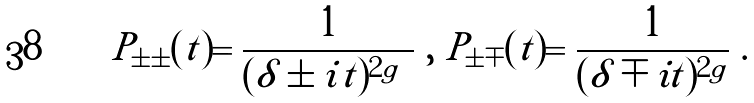Convert formula to latex. <formula><loc_0><loc_0><loc_500><loc_500>P _ { \pm \pm } ( t ) = \frac { 1 } { ( \delta \pm i | t | ) ^ { 2 g } } \ , \ P _ { \pm \mp } ( t ) = \frac { 1 } { ( \delta \mp i t ) ^ { 2 g } } \ .</formula> 